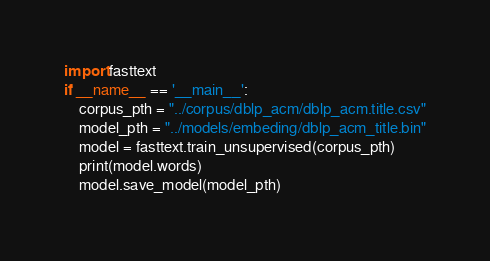<code> <loc_0><loc_0><loc_500><loc_500><_Python_>import fasttext
if __name__ == '__main__':
    corpus_pth = "../corpus/dblp_acm/dblp_acm.title.csv"
    model_pth = "../models/embeding/dblp_acm_title.bin"
    model = fasttext.train_unsupervised(corpus_pth)
    print(model.words)
    model.save_model(model_pth)</code> 